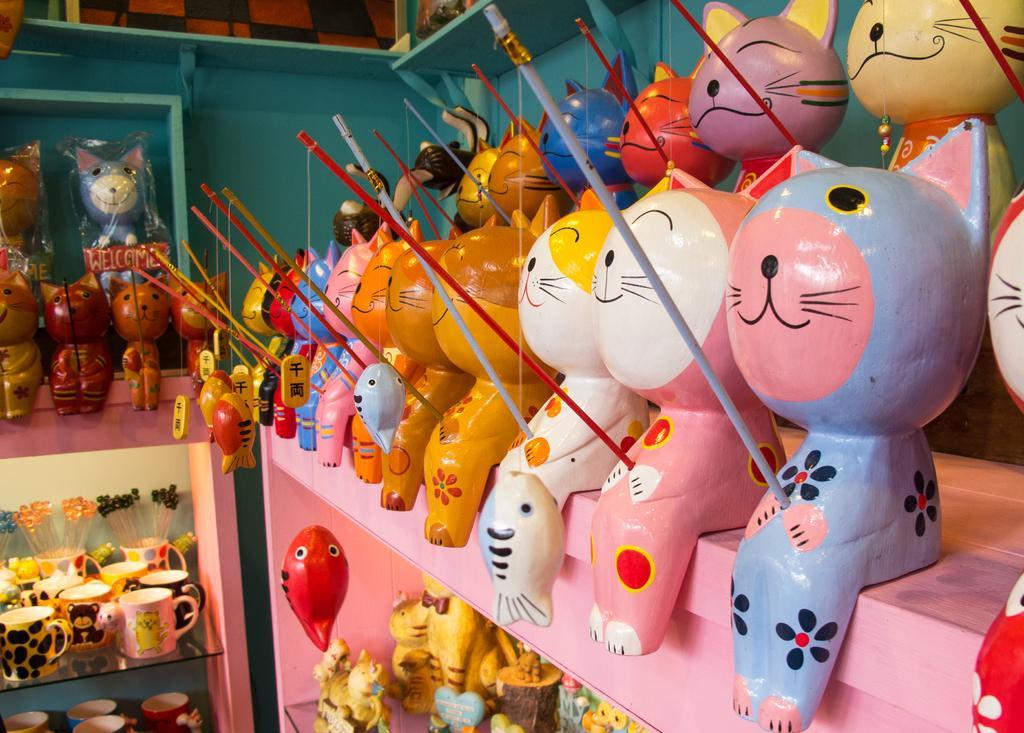Can you describe this image briefly? In this picture we can see toys, cups in racks, sticks and in the background we can see wall. 